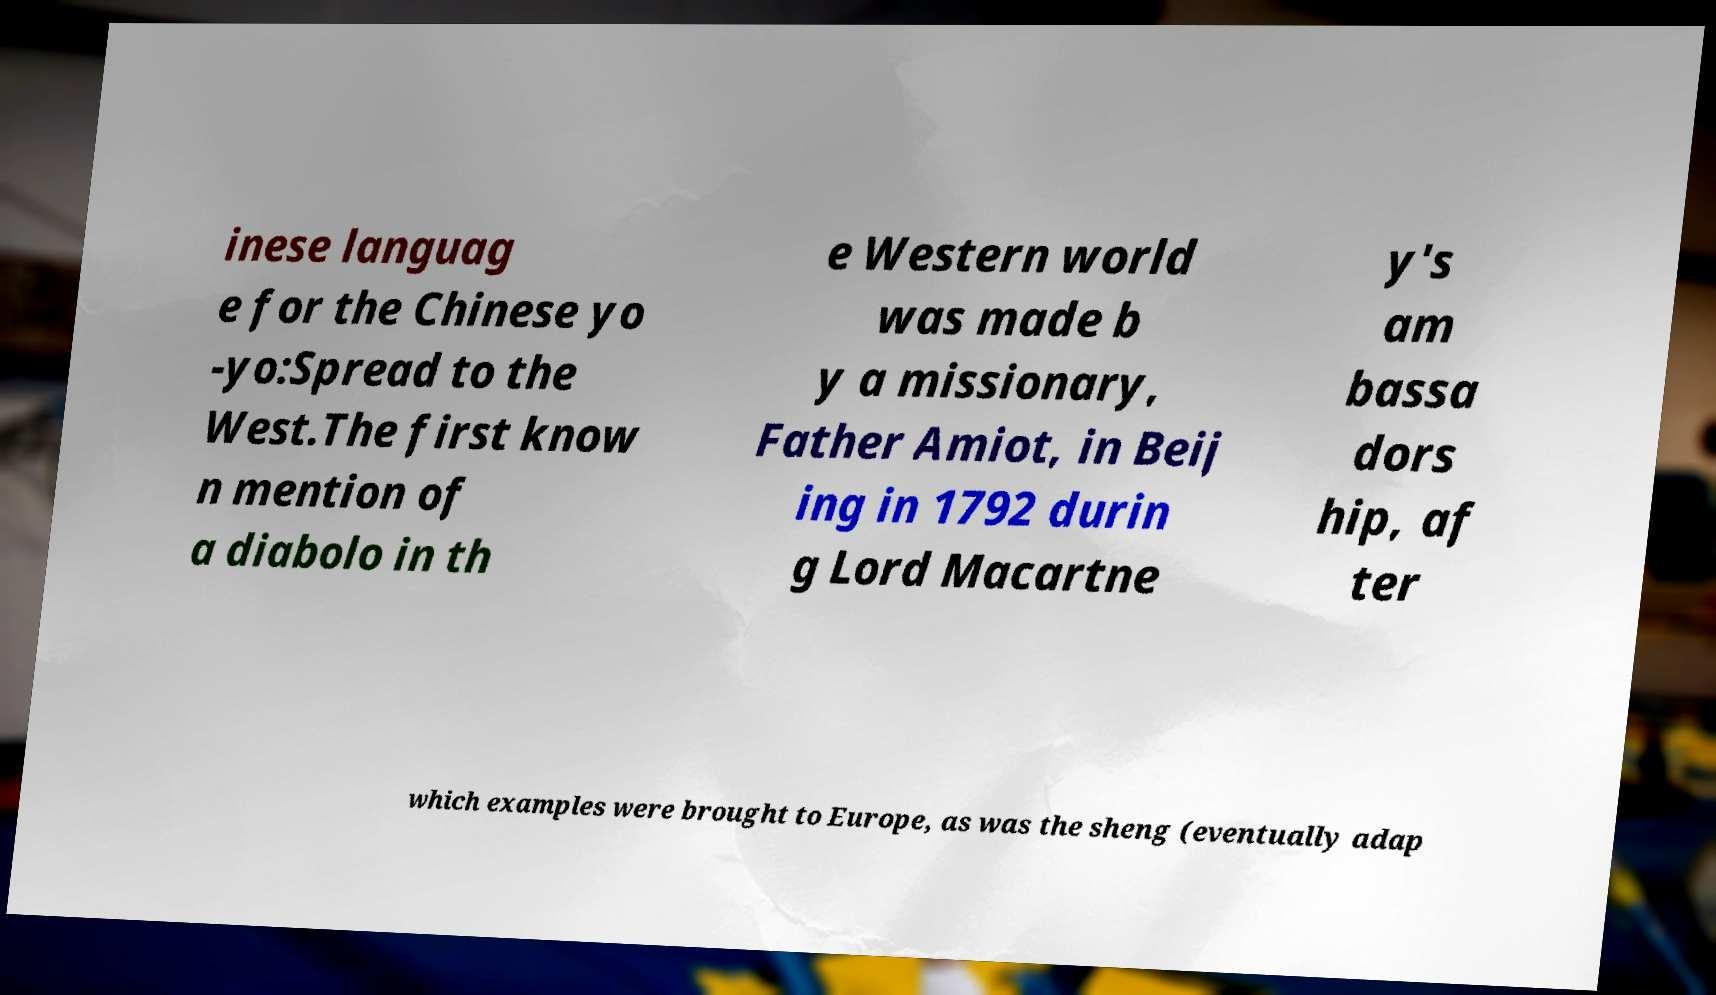Could you assist in decoding the text presented in this image and type it out clearly? inese languag e for the Chinese yo -yo:Spread to the West.The first know n mention of a diabolo in th e Western world was made b y a missionary, Father Amiot, in Beij ing in 1792 durin g Lord Macartne y's am bassa dors hip, af ter which examples were brought to Europe, as was the sheng (eventually adap 